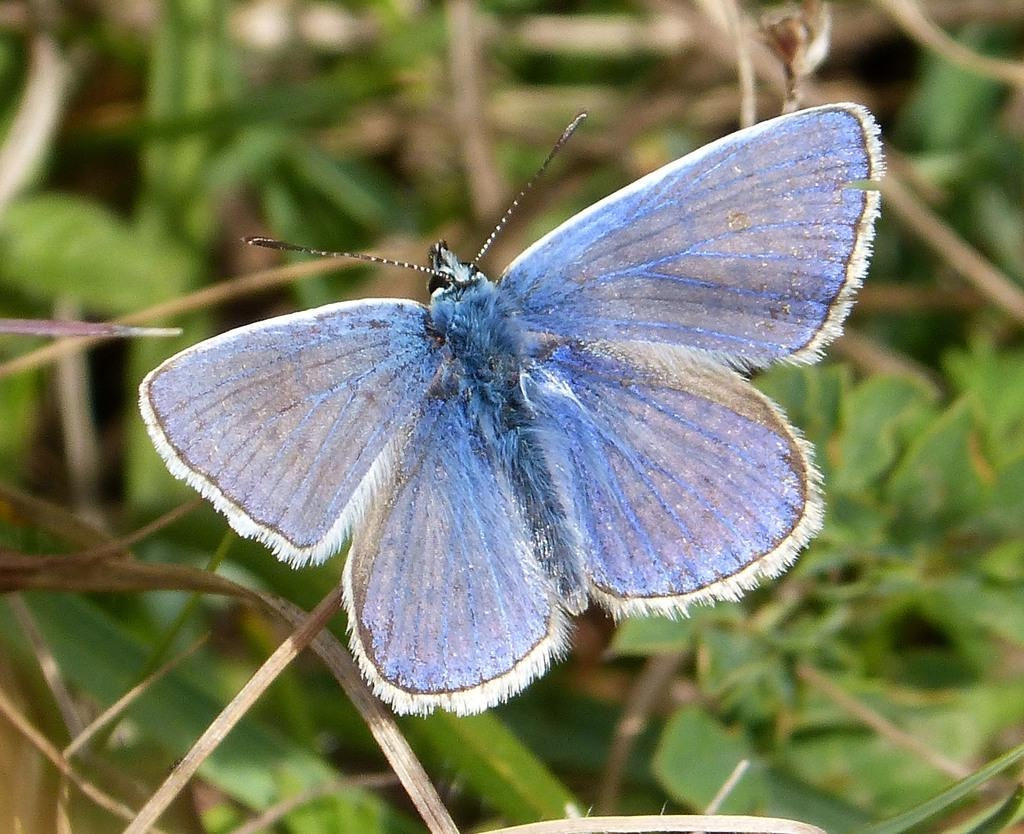What type of creature is present in the image? There is a butterfly in the image. What colors can be seen on the butterfly? The butterfly has blue and white colors. What type of vegetation is visible in the image? There are green leaves visible in the image. What month is the butterfly's discovery announced in the image? There is no mention of a discovery or a specific month in the image. 